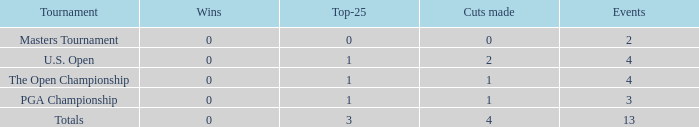How many cuts did he make at the PGA championship in 3 events? None. 